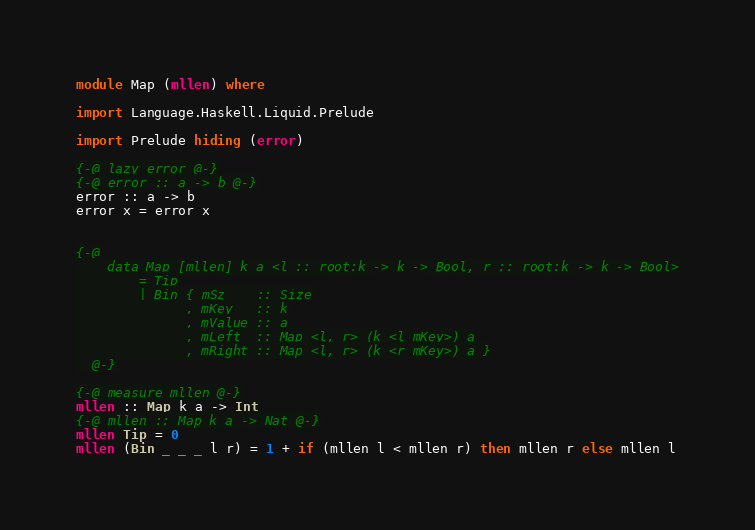Convert code to text. <code><loc_0><loc_0><loc_500><loc_500><_Haskell_>module Map (mllen) where

import Language.Haskell.Liquid.Prelude

import Prelude hiding (error)

{-@ lazy error @-}
{-@ error :: a -> b @-}
error :: a -> b
error x = error x


{-@
    data Map [mllen] k a <l :: root:k -> k -> Bool, r :: root:k -> k -> Bool>
        = Tip
        | Bin { mSz    :: Size
              , mKey   :: k
              , mValue :: a
              , mLeft  :: Map <l, r> (k <l mKey>) a
              , mRight :: Map <l, r> (k <r mKey>) a }
  @-}

{-@ measure mllen @-}
mllen :: Map k a -> Int 
{-@ mllen :: Map k a -> Nat @-}
mllen Tip = 0 
mllen (Bin _ _ _ l r) = 1 + if (mllen l < mllen r) then mllen r else mllen l

</code> 